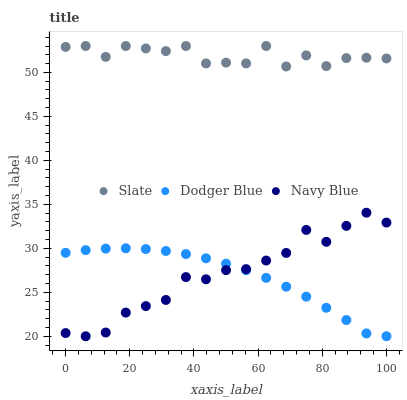Does Dodger Blue have the minimum area under the curve?
Answer yes or no. Yes. Does Slate have the maximum area under the curve?
Answer yes or no. Yes. Does Slate have the minimum area under the curve?
Answer yes or no. No. Does Dodger Blue have the maximum area under the curve?
Answer yes or no. No. Is Dodger Blue the smoothest?
Answer yes or no. Yes. Is Slate the roughest?
Answer yes or no. Yes. Is Slate the smoothest?
Answer yes or no. No. Is Dodger Blue the roughest?
Answer yes or no. No. Does Navy Blue have the lowest value?
Answer yes or no. Yes. Does Slate have the lowest value?
Answer yes or no. No. Does Slate have the highest value?
Answer yes or no. Yes. Does Dodger Blue have the highest value?
Answer yes or no. No. Is Dodger Blue less than Slate?
Answer yes or no. Yes. Is Slate greater than Navy Blue?
Answer yes or no. Yes. Does Dodger Blue intersect Navy Blue?
Answer yes or no. Yes. Is Dodger Blue less than Navy Blue?
Answer yes or no. No. Is Dodger Blue greater than Navy Blue?
Answer yes or no. No. Does Dodger Blue intersect Slate?
Answer yes or no. No. 